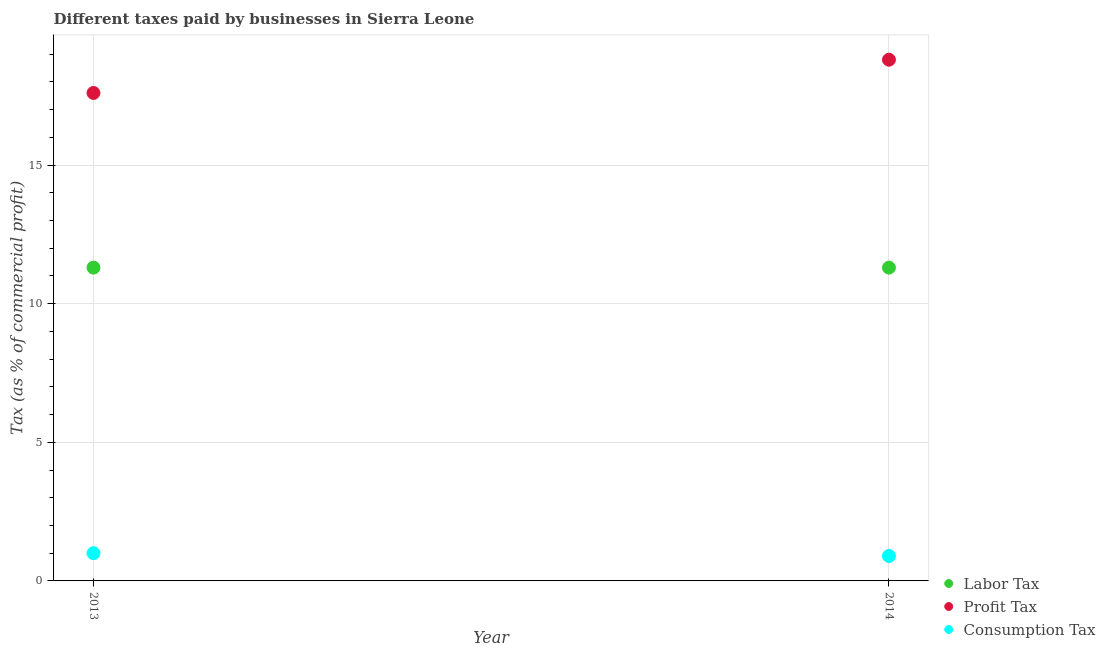How many different coloured dotlines are there?
Your answer should be compact. 3. Across all years, what is the maximum percentage of consumption tax?
Keep it short and to the point. 1. Across all years, what is the minimum percentage of profit tax?
Your response must be concise. 17.6. In which year was the percentage of labor tax maximum?
Ensure brevity in your answer.  2013. What is the total percentage of labor tax in the graph?
Your answer should be compact. 22.6. What is the difference between the percentage of consumption tax in 2013 and that in 2014?
Give a very brief answer. 0.1. What is the difference between the percentage of labor tax in 2014 and the percentage of consumption tax in 2013?
Provide a short and direct response. 10.3. In the year 2013, what is the difference between the percentage of profit tax and percentage of labor tax?
Your answer should be compact. 6.3. In how many years, is the percentage of labor tax greater than 4 %?
Keep it short and to the point. 2. What is the ratio of the percentage of profit tax in 2013 to that in 2014?
Your answer should be compact. 0.94. Is the percentage of profit tax in 2013 less than that in 2014?
Your answer should be very brief. Yes. In how many years, is the percentage of profit tax greater than the average percentage of profit tax taken over all years?
Provide a succinct answer. 1. Is it the case that in every year, the sum of the percentage of labor tax and percentage of profit tax is greater than the percentage of consumption tax?
Give a very brief answer. Yes. Is the percentage of consumption tax strictly less than the percentage of profit tax over the years?
Make the answer very short. Yes. Are the values on the major ticks of Y-axis written in scientific E-notation?
Make the answer very short. No. Does the graph contain any zero values?
Give a very brief answer. No. Where does the legend appear in the graph?
Your answer should be compact. Bottom right. What is the title of the graph?
Give a very brief answer. Different taxes paid by businesses in Sierra Leone. What is the label or title of the Y-axis?
Make the answer very short. Tax (as % of commercial profit). What is the Tax (as % of commercial profit) in Labor Tax in 2013?
Your answer should be compact. 11.3. What is the Tax (as % of commercial profit) of Labor Tax in 2014?
Make the answer very short. 11.3. What is the Tax (as % of commercial profit) in Profit Tax in 2014?
Your answer should be very brief. 18.8. What is the Tax (as % of commercial profit) in Consumption Tax in 2014?
Keep it short and to the point. 0.9. Across all years, what is the maximum Tax (as % of commercial profit) of Consumption Tax?
Offer a terse response. 1. Across all years, what is the minimum Tax (as % of commercial profit) in Labor Tax?
Ensure brevity in your answer.  11.3. Across all years, what is the minimum Tax (as % of commercial profit) in Consumption Tax?
Provide a succinct answer. 0.9. What is the total Tax (as % of commercial profit) in Labor Tax in the graph?
Give a very brief answer. 22.6. What is the total Tax (as % of commercial profit) of Profit Tax in the graph?
Provide a succinct answer. 36.4. What is the difference between the Tax (as % of commercial profit) of Consumption Tax in 2013 and that in 2014?
Ensure brevity in your answer.  0.1. What is the difference between the Tax (as % of commercial profit) of Labor Tax in 2013 and the Tax (as % of commercial profit) of Profit Tax in 2014?
Your response must be concise. -7.5. What is the average Tax (as % of commercial profit) of Labor Tax per year?
Give a very brief answer. 11.3. What is the average Tax (as % of commercial profit) in Consumption Tax per year?
Offer a terse response. 0.95. In the year 2013, what is the difference between the Tax (as % of commercial profit) in Labor Tax and Tax (as % of commercial profit) in Profit Tax?
Ensure brevity in your answer.  -6.3. In the year 2013, what is the difference between the Tax (as % of commercial profit) of Profit Tax and Tax (as % of commercial profit) of Consumption Tax?
Ensure brevity in your answer.  16.6. In the year 2014, what is the difference between the Tax (as % of commercial profit) in Profit Tax and Tax (as % of commercial profit) in Consumption Tax?
Your answer should be compact. 17.9. What is the ratio of the Tax (as % of commercial profit) of Profit Tax in 2013 to that in 2014?
Offer a very short reply. 0.94. What is the ratio of the Tax (as % of commercial profit) of Consumption Tax in 2013 to that in 2014?
Offer a very short reply. 1.11. What is the difference between the highest and the second highest Tax (as % of commercial profit) in Profit Tax?
Ensure brevity in your answer.  1.2. What is the difference between the highest and the second highest Tax (as % of commercial profit) in Consumption Tax?
Make the answer very short. 0.1. 